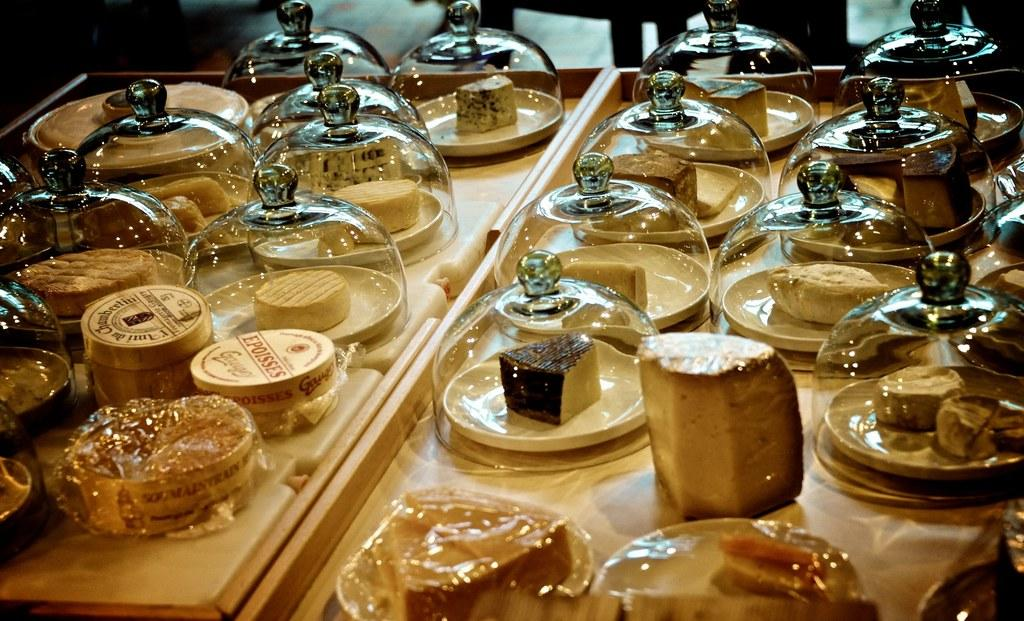What can be seen in the image? There are food items in the image. How are the food items arranged? The food items are arranged on tables. Are there any birds with tails visible in the image? There are no birds or tails present in the image; it only features food items arranged on tables. 